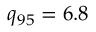Convert formula to latex. <formula><loc_0><loc_0><loc_500><loc_500>q _ { 9 5 } = 6 . 8</formula> 